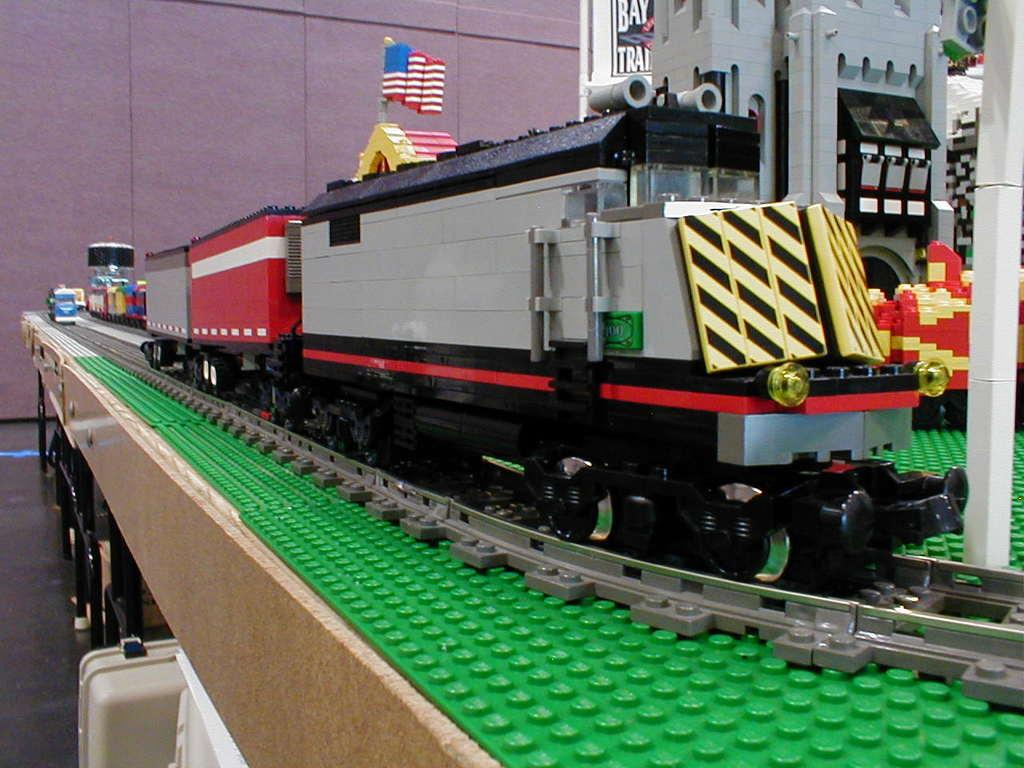What is the main subject of the image? There is a model of a train in the image. What is the train model placed on? Both the train model and railway track are on a table. What is the train model positioned on in the image? The train model is on a railway track. What can be seen in the background of the image? There is a wall visible in the background of the image. What type of ship can be seen sailing near the train model in the image? There is no ship present in the image; it only features a model of a train and a railway track on a table. How many mailboxes are visible in the image? There are no mailboxes present in the image. 